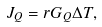<formula> <loc_0><loc_0><loc_500><loc_500>J _ { Q } = r G _ { Q } \Delta T ,</formula> 